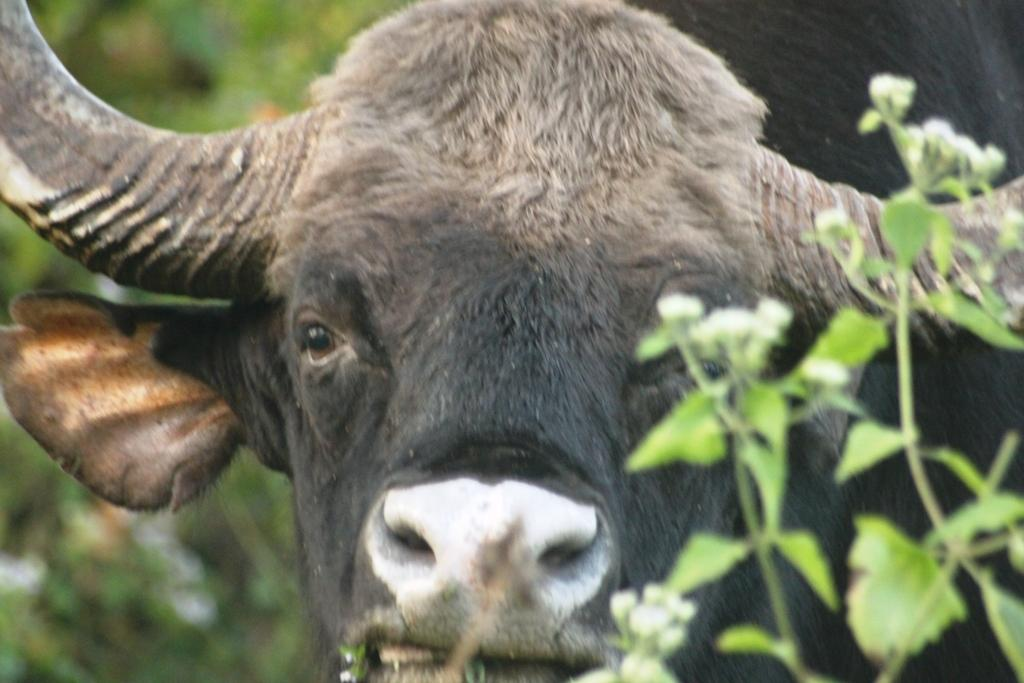What is the main subject in the center of the image? There is a buffalo in the center of the image. What can be seen in the background of the image? Plants are visible in the background of the image. What type of shirt is the buffalo wearing in the image? Buffaloes do not wear shirts, so there is no shirt present in the image. 